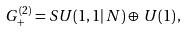<formula> <loc_0><loc_0><loc_500><loc_500>G ^ { ( 2 ) } _ { + } = S U ( 1 , 1 | \, N ) \oplus \, U ( 1 ) \, ,</formula> 